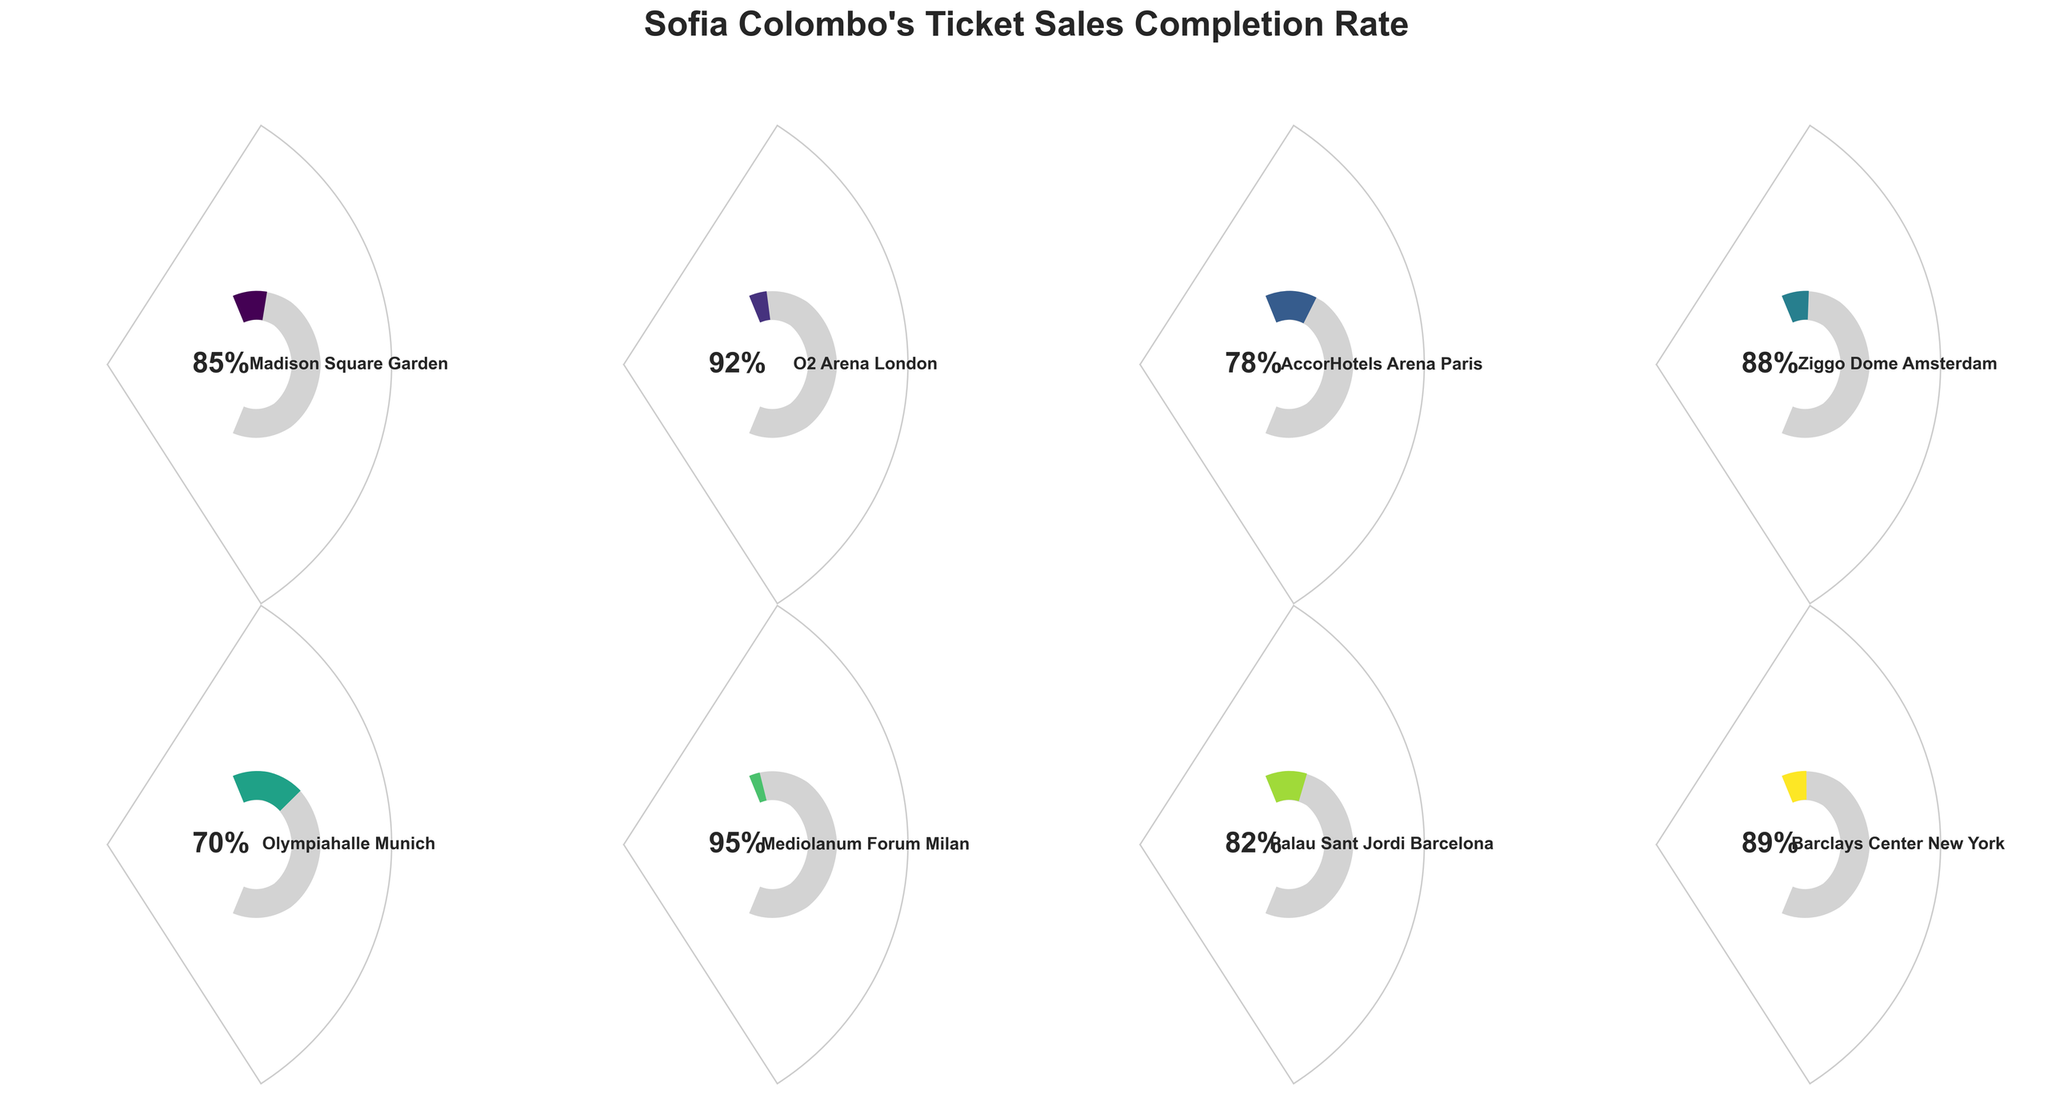What's the completion rate for Sofia Colombo's performance at Madison Square Garden? Look at the gauge chart labeled "Madison Square Garden". The number at the bottom of the gauge indicates the completion rate.
Answer: 85% Which venue has the highest ticket sales completion rate? Compare the completion rates of all venues. The highest value is at Mediolanum Forum Milan, which has a 95% rate.
Answer: Mediolanum Forum Milan How many venues have a completion rate above 80%? Identify the completion rates above 80%: Madison Square Garden (85%), O2 Arena London (92%), Ziggo Dome Amsterdam (88%), Mediolanum Forum Milan (95%), Palau Sant Jordi Barcelona (82%), and Barclays Center New York (89%). Count these venues.
Answer: 6 What is the average completion rate for Sofia Colombo's performances at all venues? Sum all completion rates: 85 + 92 + 78 + 88 + 70 + 95 + 82 + 89 = 679. Divide by the number of venues (8).
Answer: 84.875% Which venues have a completion rate below 80%? Identify the completion rates below 80%: Olympiahalle Munich (70%) and AccorHotels Arena Paris (78%).
Answer: Olympiahalle Munich, AccorHotels Arena Paris Is the ticket sales completion rate higher at Ziggo Dome Amsterdam or Barclays Center New York? Compare the completion rates of the two venues. Ziggo Dome Amsterdam is 88% and Barclays Center New York is 89%.
Answer: Barclays Center New York What is the difference in completion rate between Olympiahalle Munich and Mediolanum Forum Milan? Subtract the completion rate of Olympiahalle Munich (70%) from Mediolanum Forum Milan (95%).
Answer: 25% Which venue has the second highest ticket sales completion rate? Identify the second highest completion rate: Mediolanum Forum Milan is the highest (95%), and O2 Arena London is the second highest (92%).
Answer: O2 Arena London What's the completion rate for Sofia Colombo's performance at Palau Sant Jordi Barcelona? Look at the gauge chart labeled "Palau Sant Jordi Barcelona". The number at the bottom of the gauge indicates the completion rate.
Answer: 82% What is the median completion rate of all venues? Arrange the rates in ascending order: 70, 78, 82, 85, 88, 89, 92, 95. Since there are 8 venues, the median is the average of the 4th and 5th values: (85 + 88) / 2.
Answer: 86.5% 